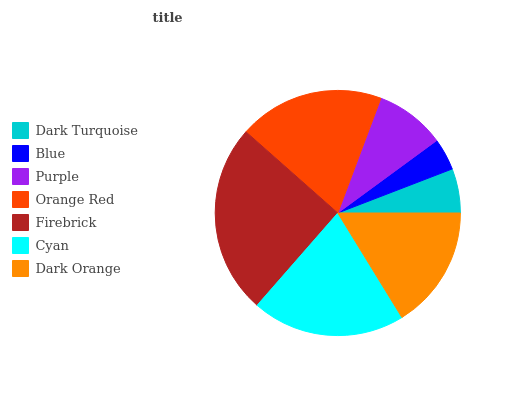Is Blue the minimum?
Answer yes or no. Yes. Is Firebrick the maximum?
Answer yes or no. Yes. Is Purple the minimum?
Answer yes or no. No. Is Purple the maximum?
Answer yes or no. No. Is Purple greater than Blue?
Answer yes or no. Yes. Is Blue less than Purple?
Answer yes or no. Yes. Is Blue greater than Purple?
Answer yes or no. No. Is Purple less than Blue?
Answer yes or no. No. Is Dark Orange the high median?
Answer yes or no. Yes. Is Dark Orange the low median?
Answer yes or no. Yes. Is Purple the high median?
Answer yes or no. No. Is Orange Red the low median?
Answer yes or no. No. 